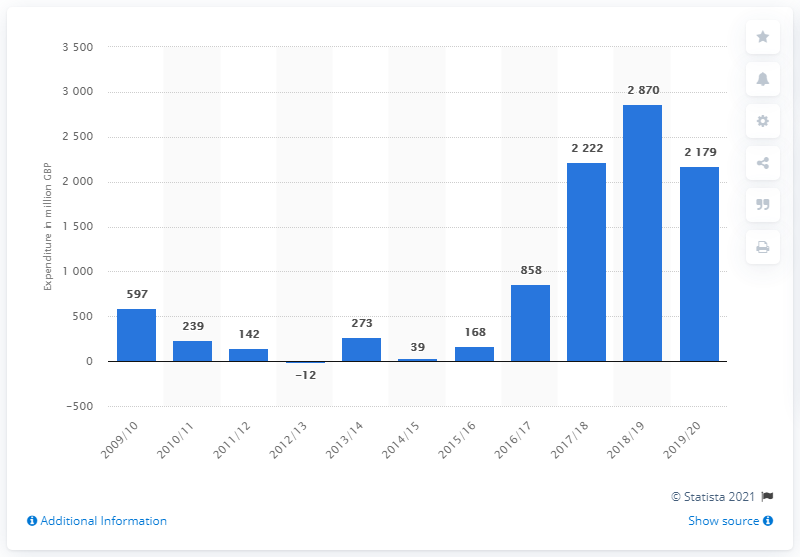Draw attention to some important aspects in this diagram. In the previous year, the UK spent a total of 2870 on mining, manufacturing, and construction. 